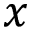Convert formula to latex. <formula><loc_0><loc_0><loc_500><loc_500>x</formula> 